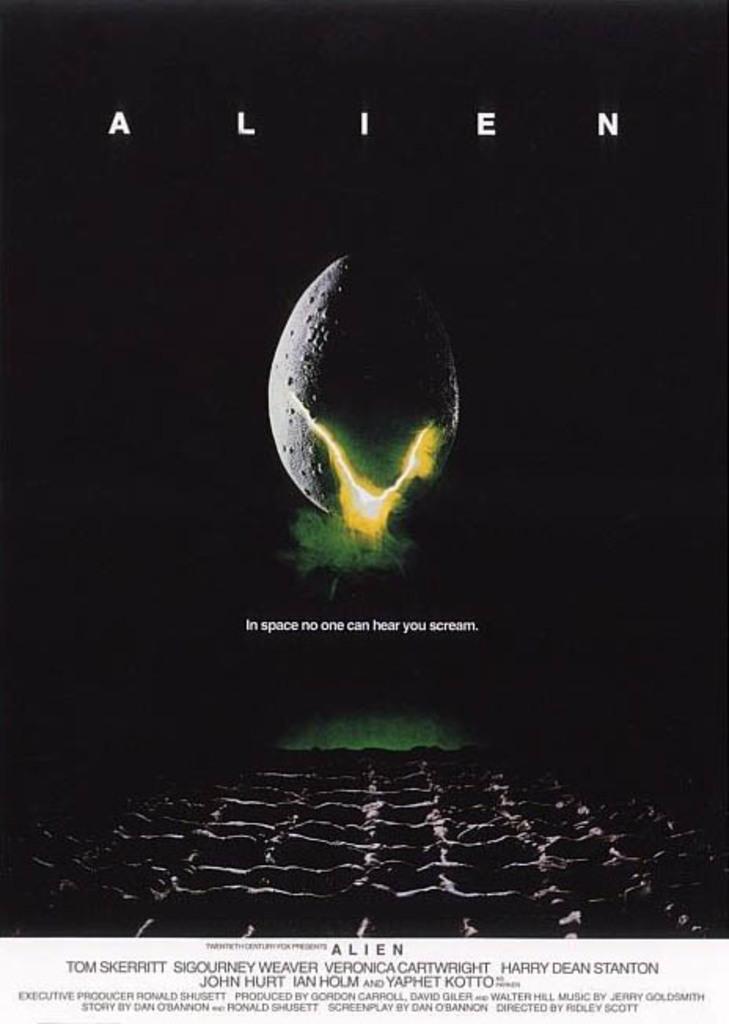What movie is this poster for?
Your response must be concise. Alien. What does the subtitle say?
Offer a terse response. In space no one can hear you scream. 